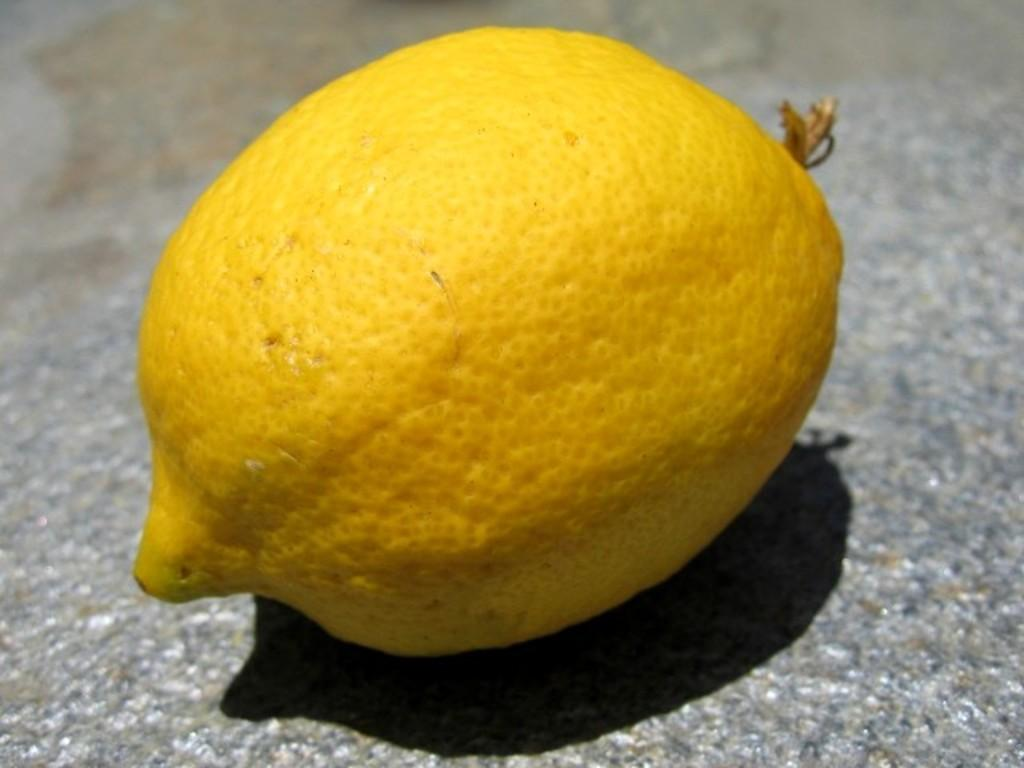What fruit is present in the image? There is a lemon in the image. What is the color of the lemon? The lemon is yellow in color. On what surface is the lemon placed? The lemon is on a surface. What colors can be seen on the surface? The surface has white, grey, and black colors. How many cars are parked next to the lemon in the image? There are no cars present in the image; it only features a lemon on a surface. Can you see a lipstick stain on the lemon in the image? There is no lipstick or lip in the image; it only features a lemon on a surface. 